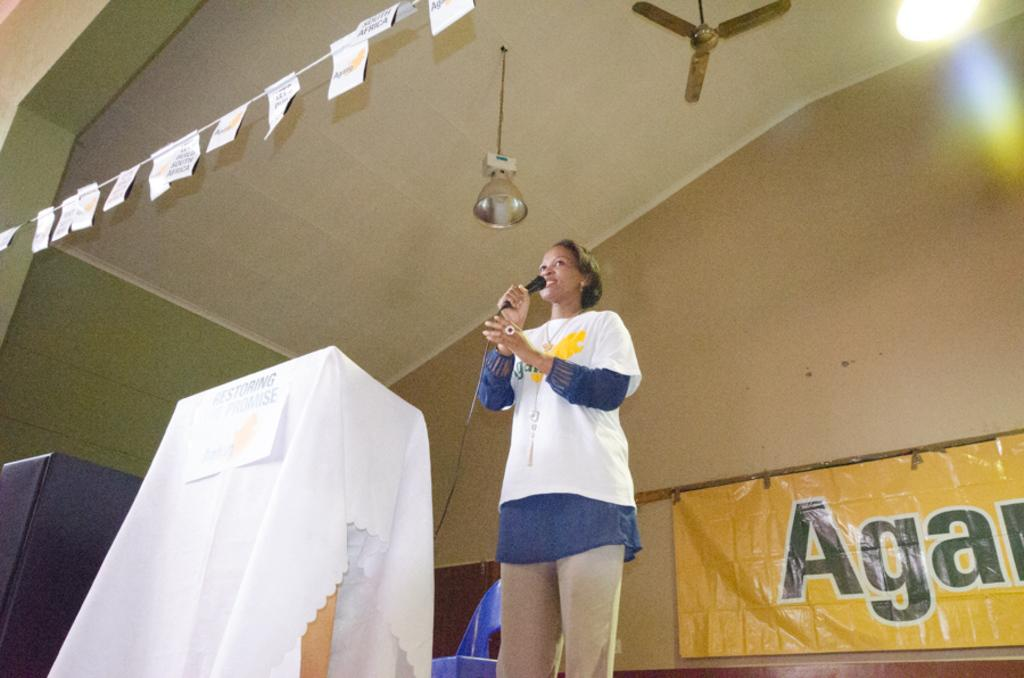<image>
Present a compact description of the photo's key features. Lady is on the stage with a microphone speaking 